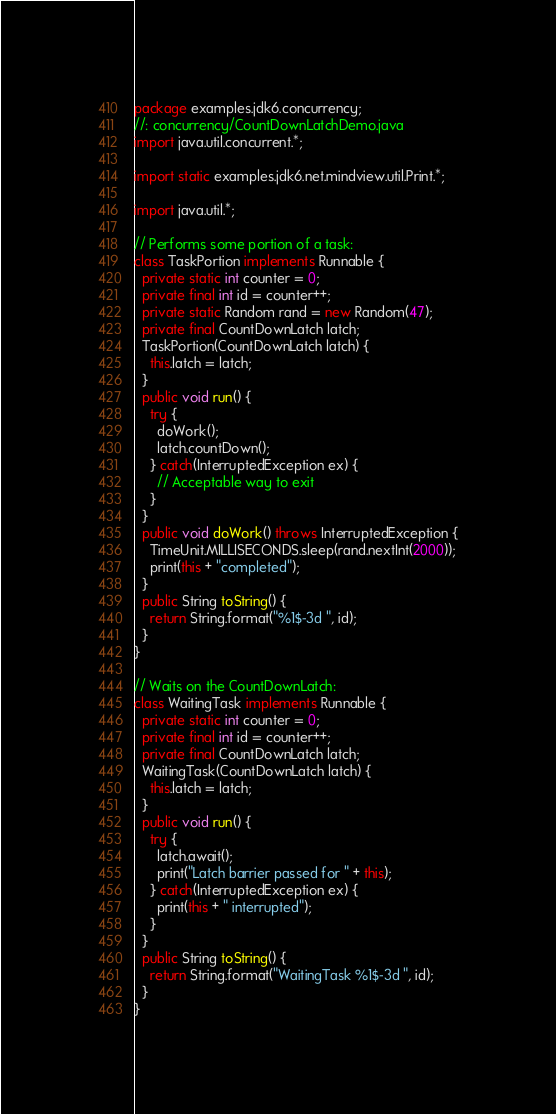<code> <loc_0><loc_0><loc_500><loc_500><_Java_>package examples.jdk6.concurrency;
//: concurrency/CountDownLatchDemo.java
import java.util.concurrent.*;

import static examples.jdk6.net.mindview.util.Print.*;

import java.util.*;

// Performs some portion of a task:
class TaskPortion implements Runnable {
  private static int counter = 0;
  private final int id = counter++;
  private static Random rand = new Random(47);
  private final CountDownLatch latch;
  TaskPortion(CountDownLatch latch) {
    this.latch = latch;
  }
  public void run() {
    try {
      doWork();
      latch.countDown();
    } catch(InterruptedException ex) {
      // Acceptable way to exit
    }
  }
  public void doWork() throws InterruptedException {
    TimeUnit.MILLISECONDS.sleep(rand.nextInt(2000));
    print(this + "completed");
  }
  public String toString() {
    return String.format("%1$-3d ", id);
  }
}

// Waits on the CountDownLatch:
class WaitingTask implements Runnable {
  private static int counter = 0;
  private final int id = counter++;
  private final CountDownLatch latch;
  WaitingTask(CountDownLatch latch) {
    this.latch = latch;
  }
  public void run() {
    try {
      latch.await();
      print("Latch barrier passed for " + this);
    } catch(InterruptedException ex) {
      print(this + " interrupted");
    }
  }
  public String toString() {
    return String.format("WaitingTask %1$-3d ", id);
  }
}
</code> 